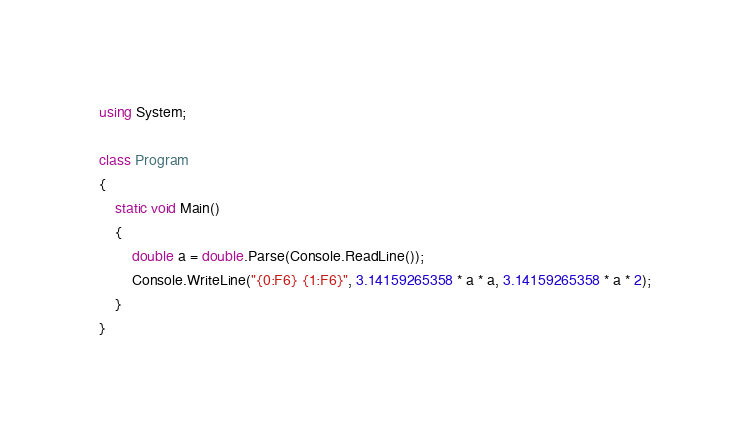<code> <loc_0><loc_0><loc_500><loc_500><_C#_>using System;

class Program
{
	static void Main()
	{
		double a = double.Parse(Console.ReadLine());
		Console.WriteLine("{0:F6} {1:F6}", 3.14159265358 * a * a, 3.14159265358 * a * 2);
	}
}</code> 